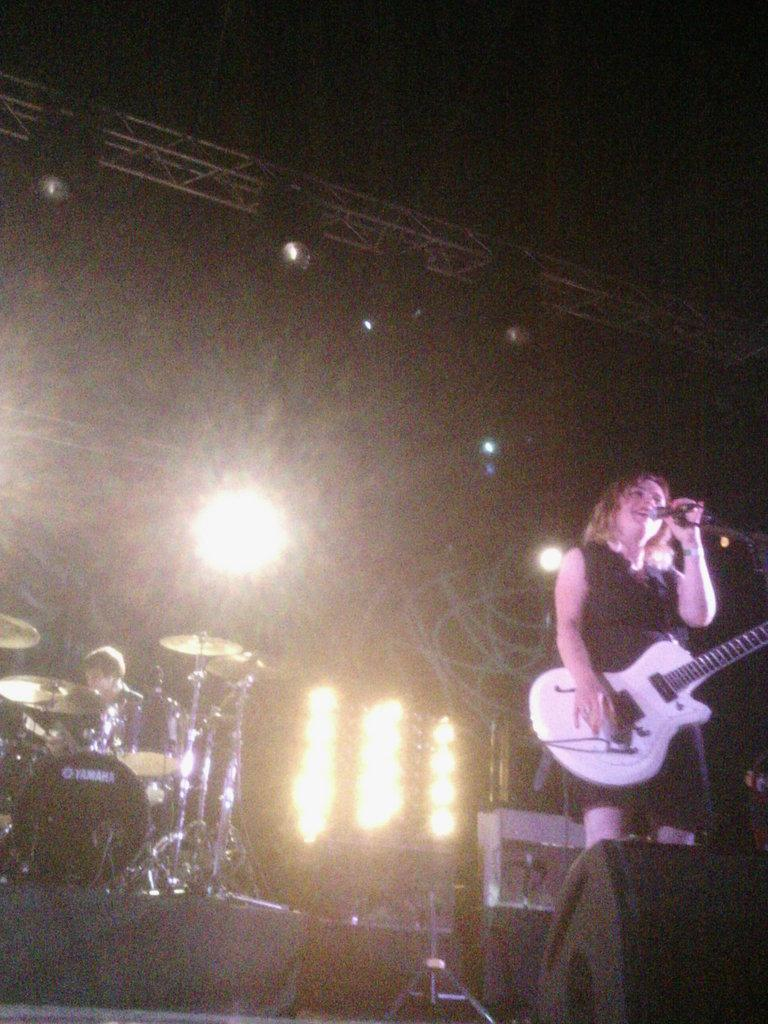What is the woman in the image doing? The woman is holding a guitar and singing into a microphone. What is the man in the image doing? The man is playing drums. Can you describe the instruments being played in the image? The woman is playing a guitar, and the man is playing drums. How many sheep are visible in the image? There are no sheep present in the image. What type of balls are being used in the image? There are no balls present in the image. 